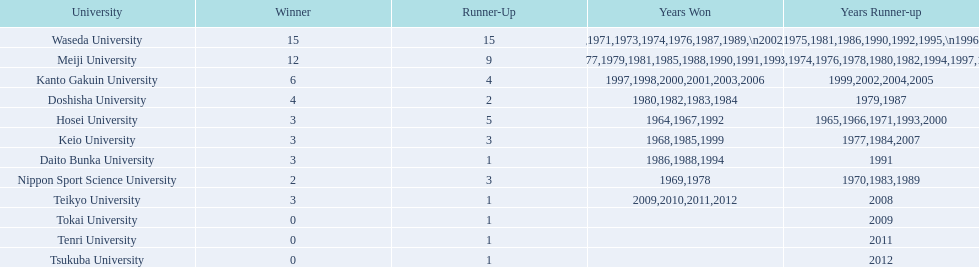What is the total number of championships held by nippon sport science university? 2. 